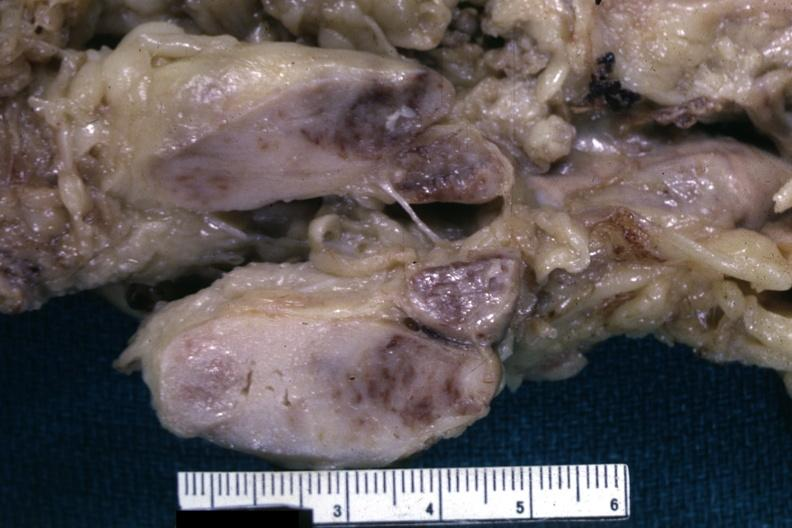what is this fixed tissue cut?
Answer the question using a single word or phrase. Surface of nodes shows infiltrative lesion quite well and does not show matting history of case unknown could have been a seminoma see other slides 